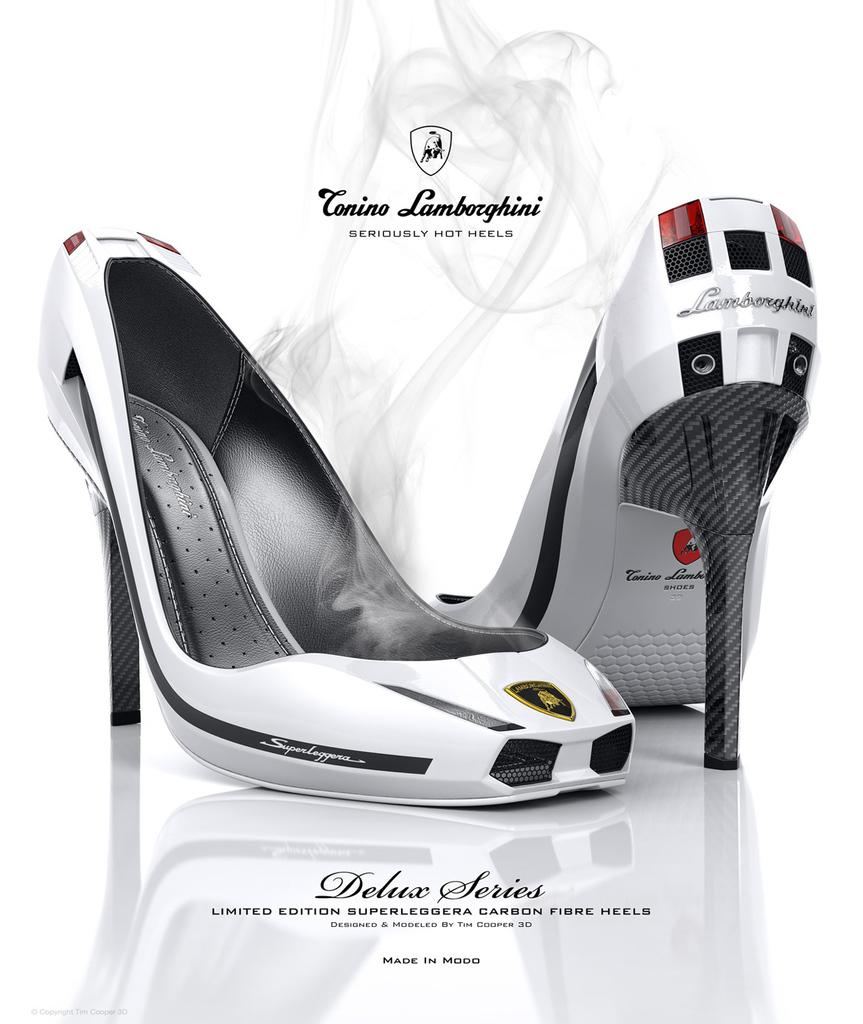What type of object is present in the image? There is footwear in the image. What colors can be seen on the footwear? The footwear has white and black colors. Is there any text visible in the image? Yes, there is text on the bottom of the image. What is the color of the background in the image? The background of the image is white. How many pieces of quartz are visible in the image? There is no quartz present in the image. What stage of development is the fork in the image? There is no fork present in the image. 